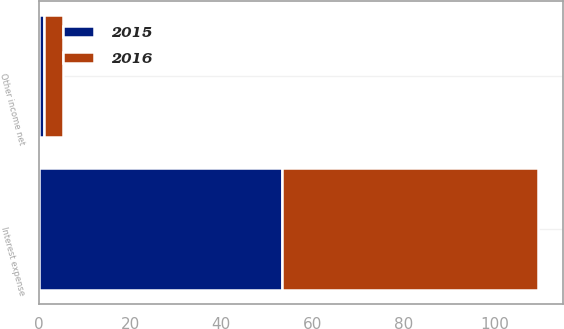<chart> <loc_0><loc_0><loc_500><loc_500><stacked_bar_chart><ecel><fcel>Interest expense<fcel>Other income net<nl><fcel>2016<fcel>56<fcel>4.2<nl><fcel>2015<fcel>53.3<fcel>1.1<nl></chart> 